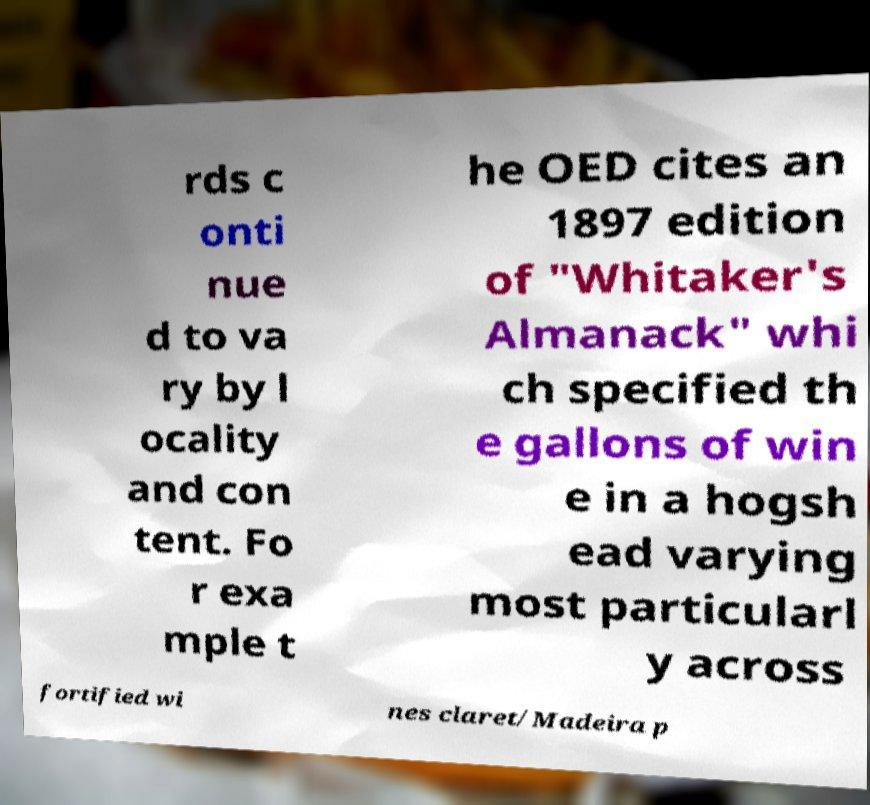Can you accurately transcribe the text from the provided image for me? rds c onti nue d to va ry by l ocality and con tent. Fo r exa mple t he OED cites an 1897 edition of "Whitaker's Almanack" whi ch specified th e gallons of win e in a hogsh ead varying most particularl y across fortified wi nes claret/Madeira p 